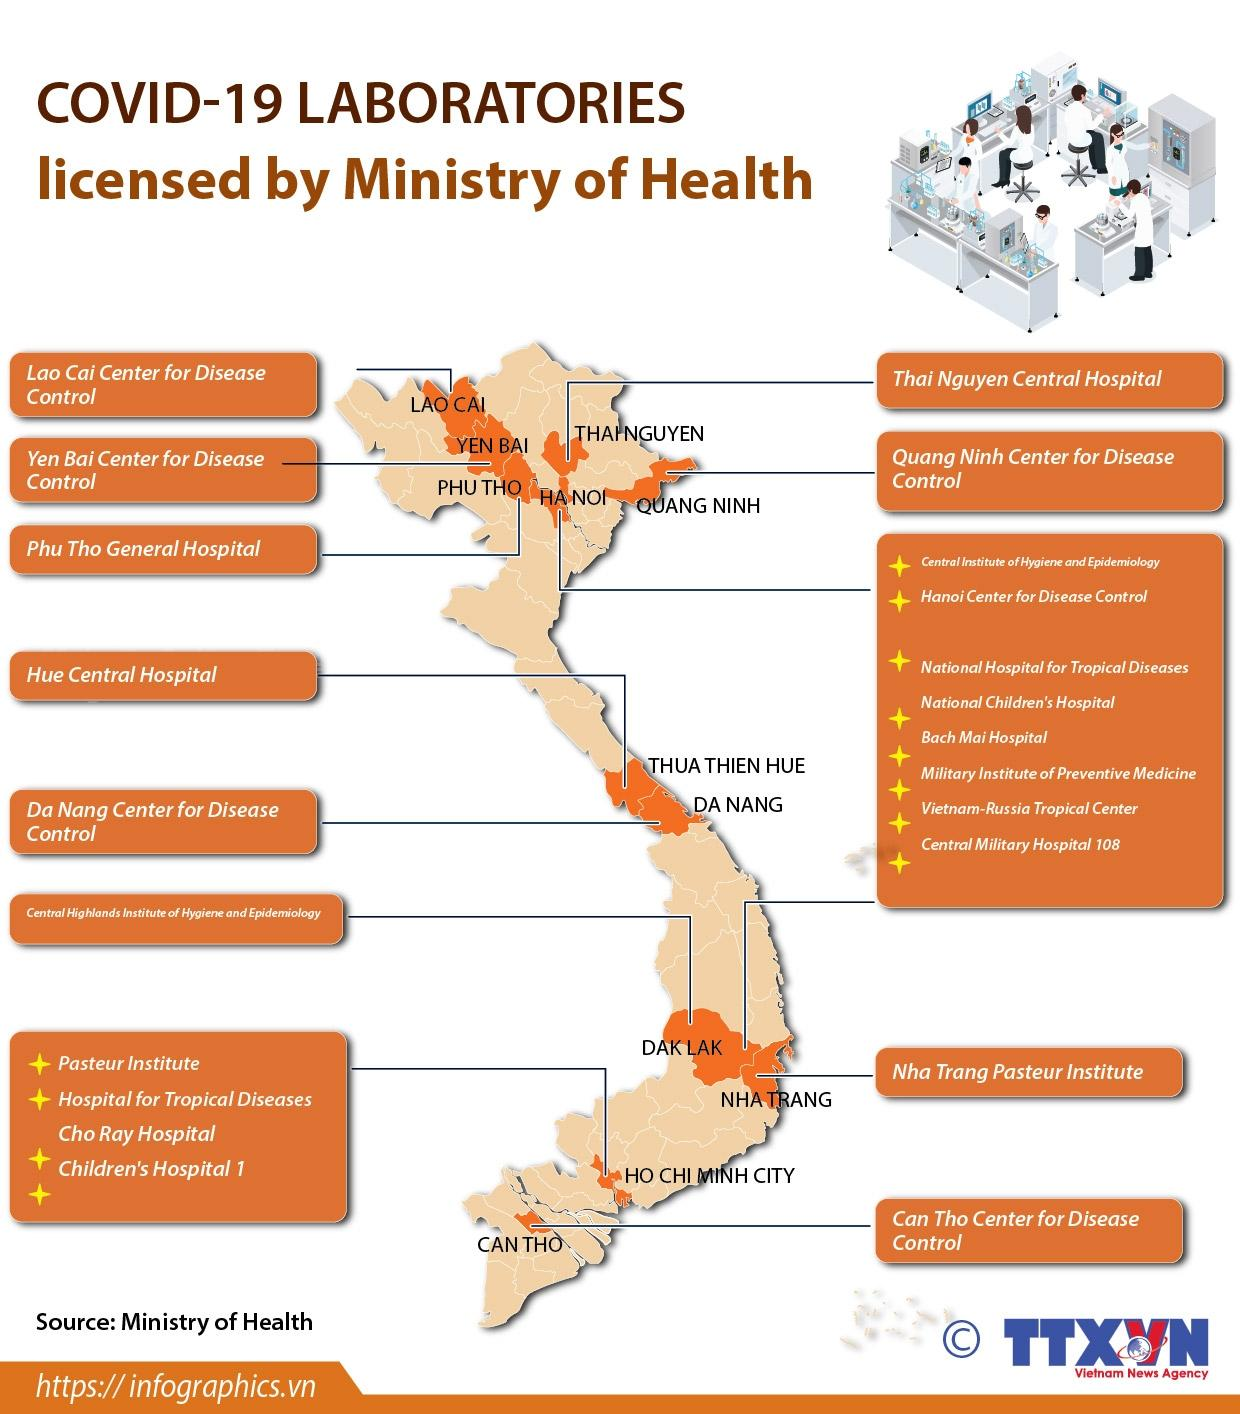Give some essential details in this illustration. Two central hospitals are featured in this infographic. The infographic contains 6 disease control centers. 